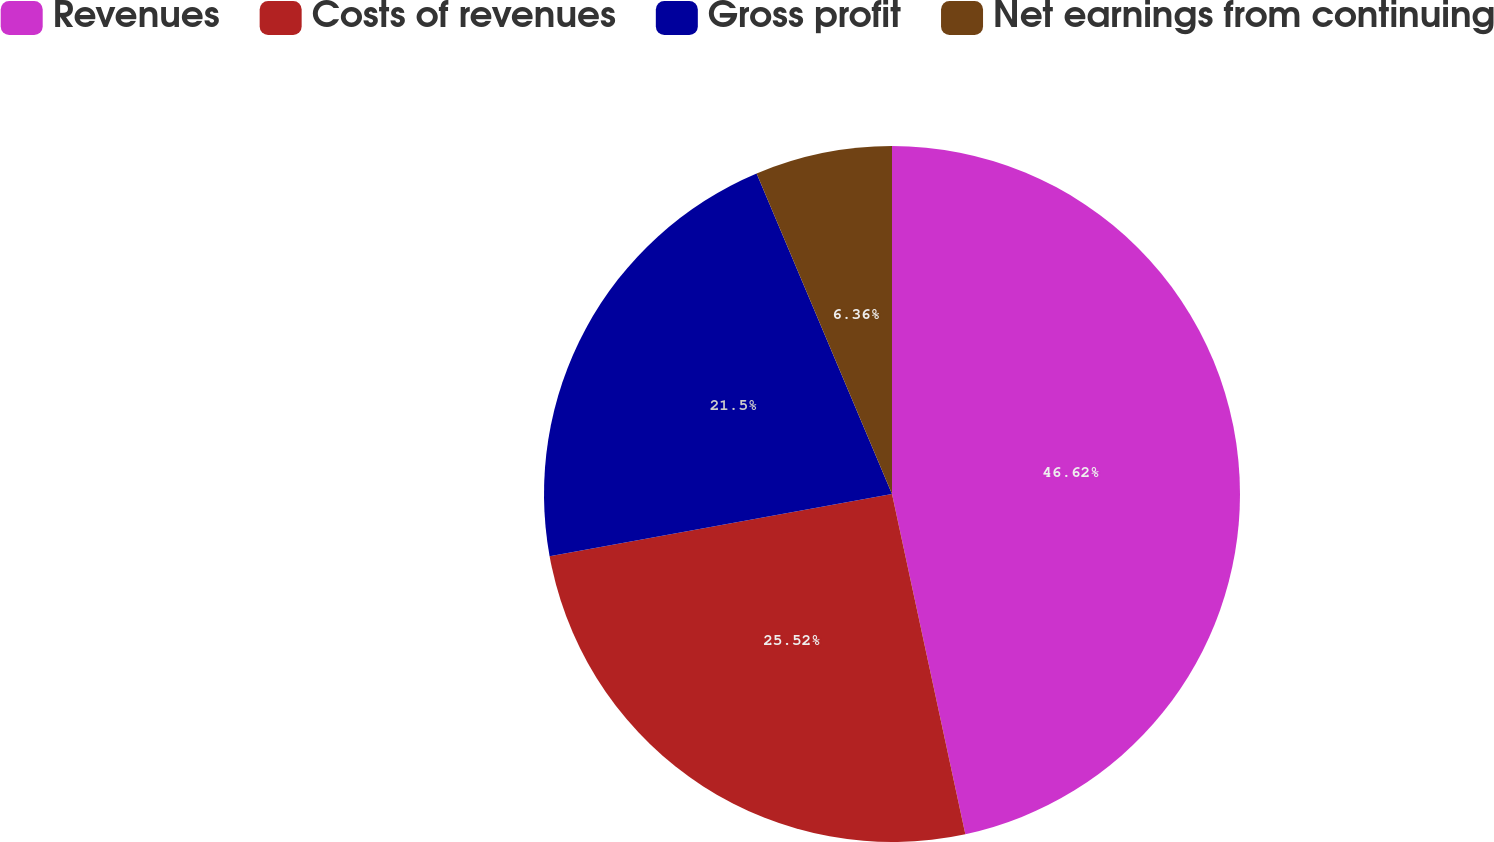<chart> <loc_0><loc_0><loc_500><loc_500><pie_chart><fcel>Revenues<fcel>Costs of revenues<fcel>Gross profit<fcel>Net earnings from continuing<nl><fcel>46.62%<fcel>25.52%<fcel>21.5%<fcel>6.36%<nl></chart> 